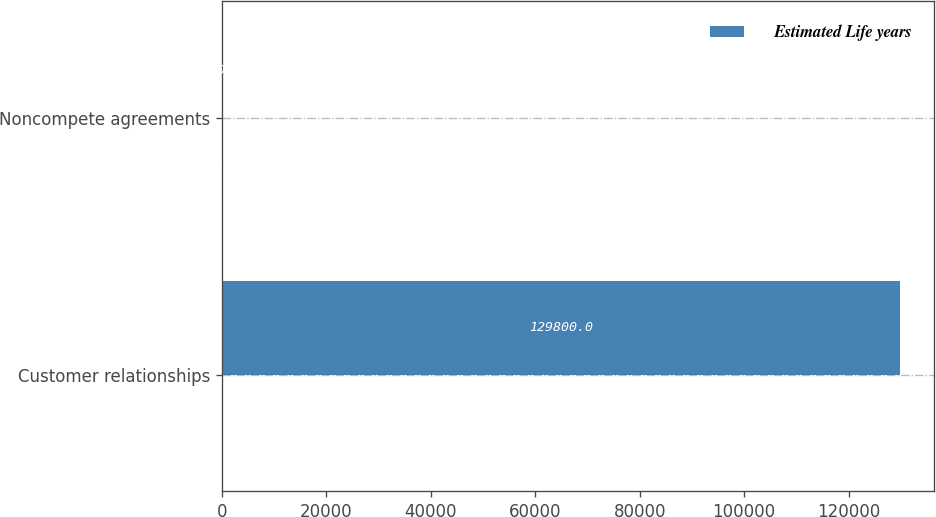Convert chart. <chart><loc_0><loc_0><loc_500><loc_500><stacked_bar_chart><ecel><fcel>Customer relationships<fcel>Noncompete agreements<nl><fcel>nan<fcel>8<fcel>5<nl><fcel>Estimated Life years<fcel>129800<fcel>200<nl></chart> 